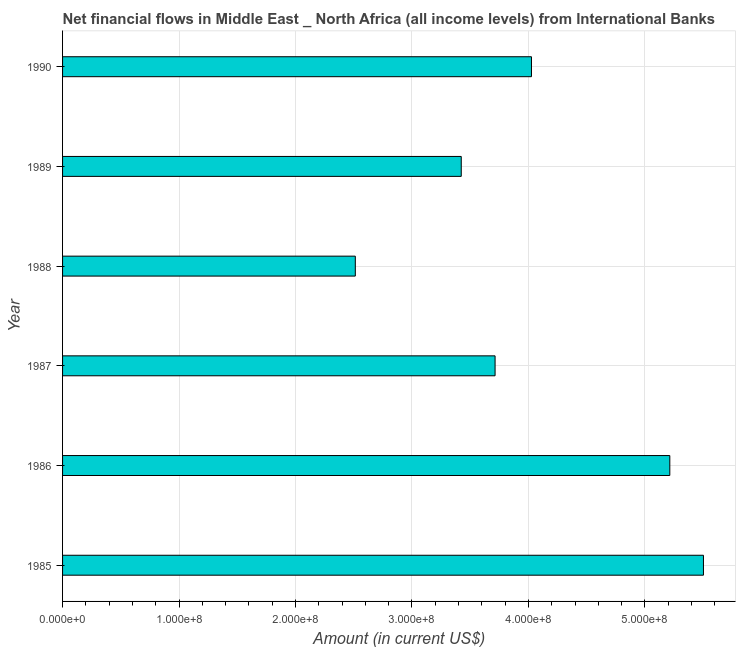Does the graph contain any zero values?
Provide a succinct answer. No. Does the graph contain grids?
Offer a terse response. Yes. What is the title of the graph?
Your response must be concise. Net financial flows in Middle East _ North Africa (all income levels) from International Banks. What is the label or title of the Y-axis?
Give a very brief answer. Year. What is the net financial flows from ibrd in 1986?
Make the answer very short. 5.21e+08. Across all years, what is the maximum net financial flows from ibrd?
Give a very brief answer. 5.50e+08. Across all years, what is the minimum net financial flows from ibrd?
Provide a short and direct response. 2.51e+08. In which year was the net financial flows from ibrd maximum?
Provide a succinct answer. 1985. In which year was the net financial flows from ibrd minimum?
Your response must be concise. 1988. What is the sum of the net financial flows from ibrd?
Ensure brevity in your answer.  2.44e+09. What is the difference between the net financial flows from ibrd in 1987 and 1989?
Make the answer very short. 2.90e+07. What is the average net financial flows from ibrd per year?
Make the answer very short. 4.07e+08. What is the median net financial flows from ibrd?
Provide a short and direct response. 3.87e+08. What is the ratio of the net financial flows from ibrd in 1985 to that in 1986?
Your response must be concise. 1.05. Is the difference between the net financial flows from ibrd in 1985 and 1989 greater than the difference between any two years?
Your answer should be very brief. No. What is the difference between the highest and the second highest net financial flows from ibrd?
Ensure brevity in your answer.  2.89e+07. What is the difference between the highest and the lowest net financial flows from ibrd?
Ensure brevity in your answer.  2.99e+08. How many years are there in the graph?
Give a very brief answer. 6. What is the difference between two consecutive major ticks on the X-axis?
Keep it short and to the point. 1.00e+08. What is the Amount (in current US$) of 1985?
Give a very brief answer. 5.50e+08. What is the Amount (in current US$) of 1986?
Your response must be concise. 5.21e+08. What is the Amount (in current US$) of 1987?
Your response must be concise. 3.71e+08. What is the Amount (in current US$) of 1988?
Ensure brevity in your answer.  2.51e+08. What is the Amount (in current US$) of 1989?
Give a very brief answer. 3.42e+08. What is the Amount (in current US$) in 1990?
Give a very brief answer. 4.03e+08. What is the difference between the Amount (in current US$) in 1985 and 1986?
Provide a succinct answer. 2.89e+07. What is the difference between the Amount (in current US$) in 1985 and 1987?
Give a very brief answer. 1.79e+08. What is the difference between the Amount (in current US$) in 1985 and 1988?
Your answer should be very brief. 2.99e+08. What is the difference between the Amount (in current US$) in 1985 and 1989?
Make the answer very short. 2.08e+08. What is the difference between the Amount (in current US$) in 1985 and 1990?
Ensure brevity in your answer.  1.48e+08. What is the difference between the Amount (in current US$) in 1986 and 1987?
Your answer should be compact. 1.50e+08. What is the difference between the Amount (in current US$) in 1986 and 1988?
Offer a very short reply. 2.70e+08. What is the difference between the Amount (in current US$) in 1986 and 1989?
Provide a succinct answer. 1.79e+08. What is the difference between the Amount (in current US$) in 1986 and 1990?
Provide a succinct answer. 1.19e+08. What is the difference between the Amount (in current US$) in 1987 and 1988?
Give a very brief answer. 1.20e+08. What is the difference between the Amount (in current US$) in 1987 and 1989?
Keep it short and to the point. 2.90e+07. What is the difference between the Amount (in current US$) in 1987 and 1990?
Your response must be concise. -3.12e+07. What is the difference between the Amount (in current US$) in 1988 and 1989?
Keep it short and to the point. -9.09e+07. What is the difference between the Amount (in current US$) in 1988 and 1990?
Make the answer very short. -1.51e+08. What is the difference between the Amount (in current US$) in 1989 and 1990?
Provide a short and direct response. -6.03e+07. What is the ratio of the Amount (in current US$) in 1985 to that in 1986?
Offer a very short reply. 1.05. What is the ratio of the Amount (in current US$) in 1985 to that in 1987?
Offer a very short reply. 1.48. What is the ratio of the Amount (in current US$) in 1985 to that in 1988?
Your answer should be very brief. 2.19. What is the ratio of the Amount (in current US$) in 1985 to that in 1989?
Offer a terse response. 1.61. What is the ratio of the Amount (in current US$) in 1985 to that in 1990?
Provide a succinct answer. 1.37. What is the ratio of the Amount (in current US$) in 1986 to that in 1987?
Ensure brevity in your answer.  1.4. What is the ratio of the Amount (in current US$) in 1986 to that in 1988?
Your response must be concise. 2.07. What is the ratio of the Amount (in current US$) in 1986 to that in 1989?
Provide a short and direct response. 1.52. What is the ratio of the Amount (in current US$) in 1986 to that in 1990?
Give a very brief answer. 1.29. What is the ratio of the Amount (in current US$) in 1987 to that in 1988?
Provide a succinct answer. 1.48. What is the ratio of the Amount (in current US$) in 1987 to that in 1989?
Give a very brief answer. 1.08. What is the ratio of the Amount (in current US$) in 1987 to that in 1990?
Offer a terse response. 0.92. What is the ratio of the Amount (in current US$) in 1988 to that in 1989?
Provide a succinct answer. 0.73. What is the ratio of the Amount (in current US$) in 1988 to that in 1990?
Ensure brevity in your answer.  0.62. 